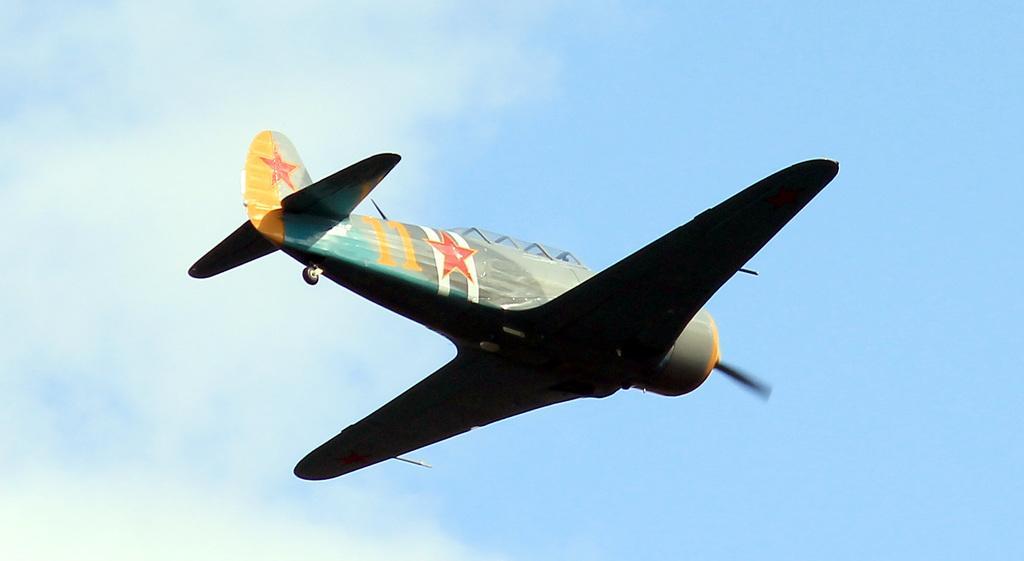Please provide a concise description of this image. We can see airplane in the air and we can see sky. 